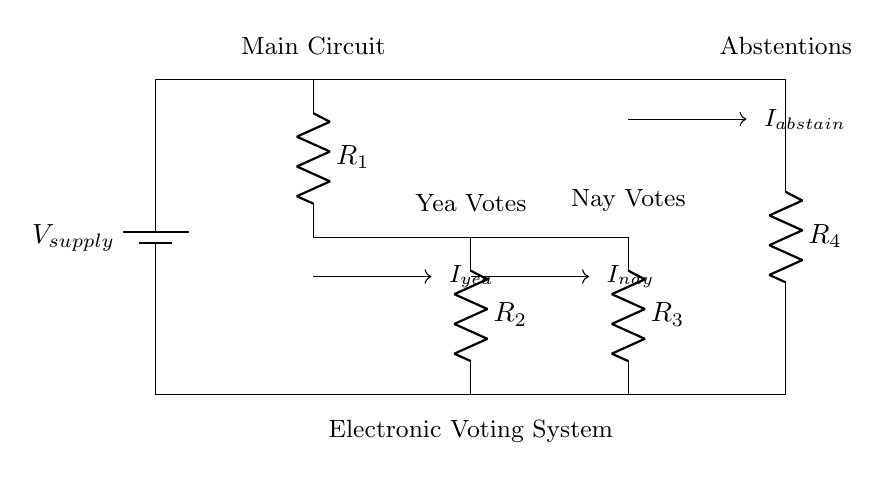What are the resistors used in the circuit? The circuit contains four resistors labeled R1, R2, R3, and R4, which are all part of the current divider configuration.
Answer: R1, R2, R3, R4 What do the current arrows indicate in the circuit? The current arrows indicate the direction of current flow through each component. In this circuit, they represent the currents for yea votes, nay votes, and abstentions.
Answer: Current flow direction What is the purpose of the resistors in this circuit? The resistors are used to divide the supply voltage among the different branches, allowing for the measurement of different voting outcomes.
Answer: Voltage division Which branch has the least resistance? Without the specific values of each resistor, it cannot be determined directly, but in a typical current divider, the branch with the lowest resistance would carry the most current.
Answer: Cannot determine without values How many branches are present in the circuit? The circuit has three branches, corresponding to yea votes, nay votes, and abstentions. Each of these branches is connected to the main circuit.
Answer: Three branches What is the total current entering the circuit? The total current entering the circuit is not specified in the diagram but would typically be equal to the sum of the currents through each branch in a current divider.
Answer: Not specified What is the main function of this electronic voting system according to the diagram? The main function of this electronic voting system is to tally votes on proposed laws, as indicated by the labeling of each branch in the circuit diagram.
Answer: Tallying votes 